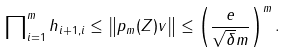Convert formula to latex. <formula><loc_0><loc_0><loc_500><loc_500>\prod \nolimits _ { i = 1 } ^ { m } h _ { i + 1 , i } \leq \left \| p _ { m } ( Z ) v \right \| \leq \left ( \frac { e } { \sqrt { \delta } m } \right ) ^ { m } .</formula> 